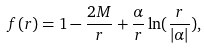Convert formula to latex. <formula><loc_0><loc_0><loc_500><loc_500>f ( r ) = 1 - \frac { 2 M } { r } + \frac { \alpha } { r } \ln ( \frac { r } { | \alpha | } ) ,</formula> 